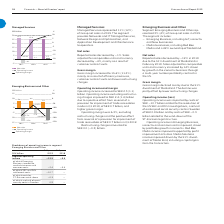According to Lm Ericsson Telephone's financial document, What is the reason that gross margin declined? the 51% divestment of MediaKind. The document states: "s Reported sales decreased by –19% in 2019 due to the 51% divestment of MediaKind in February 2019. Sales adjusted for comparable units and currency i..." Also, What is the full year 2018 operating income? Based on the financial document, the answer is -5.4 (in billions). Also, What is the full year 2019 operating income? Based on the financial document, the answer is -12.5 (in billions). Also, can you calculate: What is the total segment operating income for 2019 and 2018? Based on the calculation: -12.5+(-5.4), the result is -17.9 (in billions). This is based on the information: "–15.4% –12.5..." The key data points involved are: 12.5, 5.4. Also, can you calculate: What is the change in income from Emerging Business, iconective, media businesses and common costs in 2019 and 2018? Based on the calculation: -2.4-(-5.4), the result is 3 (in billions). This is based on the information: "Segment operating income –12.5 –5.4 of which Emerging Business, iconective, media businesses and common costs –2.4 –5.4 of which SEC an s, iconective, media businesses and common costs –2.4 –5.4 of wh..." The key data points involved are: 2.4, 5.4. Also, can you calculate: What is the proportion of sec and doj settlement costs in its segment operating income in 2019? To answer this question, I need to perform calculations using the financial data. The calculation is: -10.7/-12.5, which equals 85.6 (percentage). This is based on the information: "–2.4 –5.4 of which SEC and DOJ settlement costs –10.7 – of which costs for ST-Ericsson wind-down –0.3 – of which a refund of social security costs in Swe –12.5..." The key data points involved are: 10.7, 12.5. 